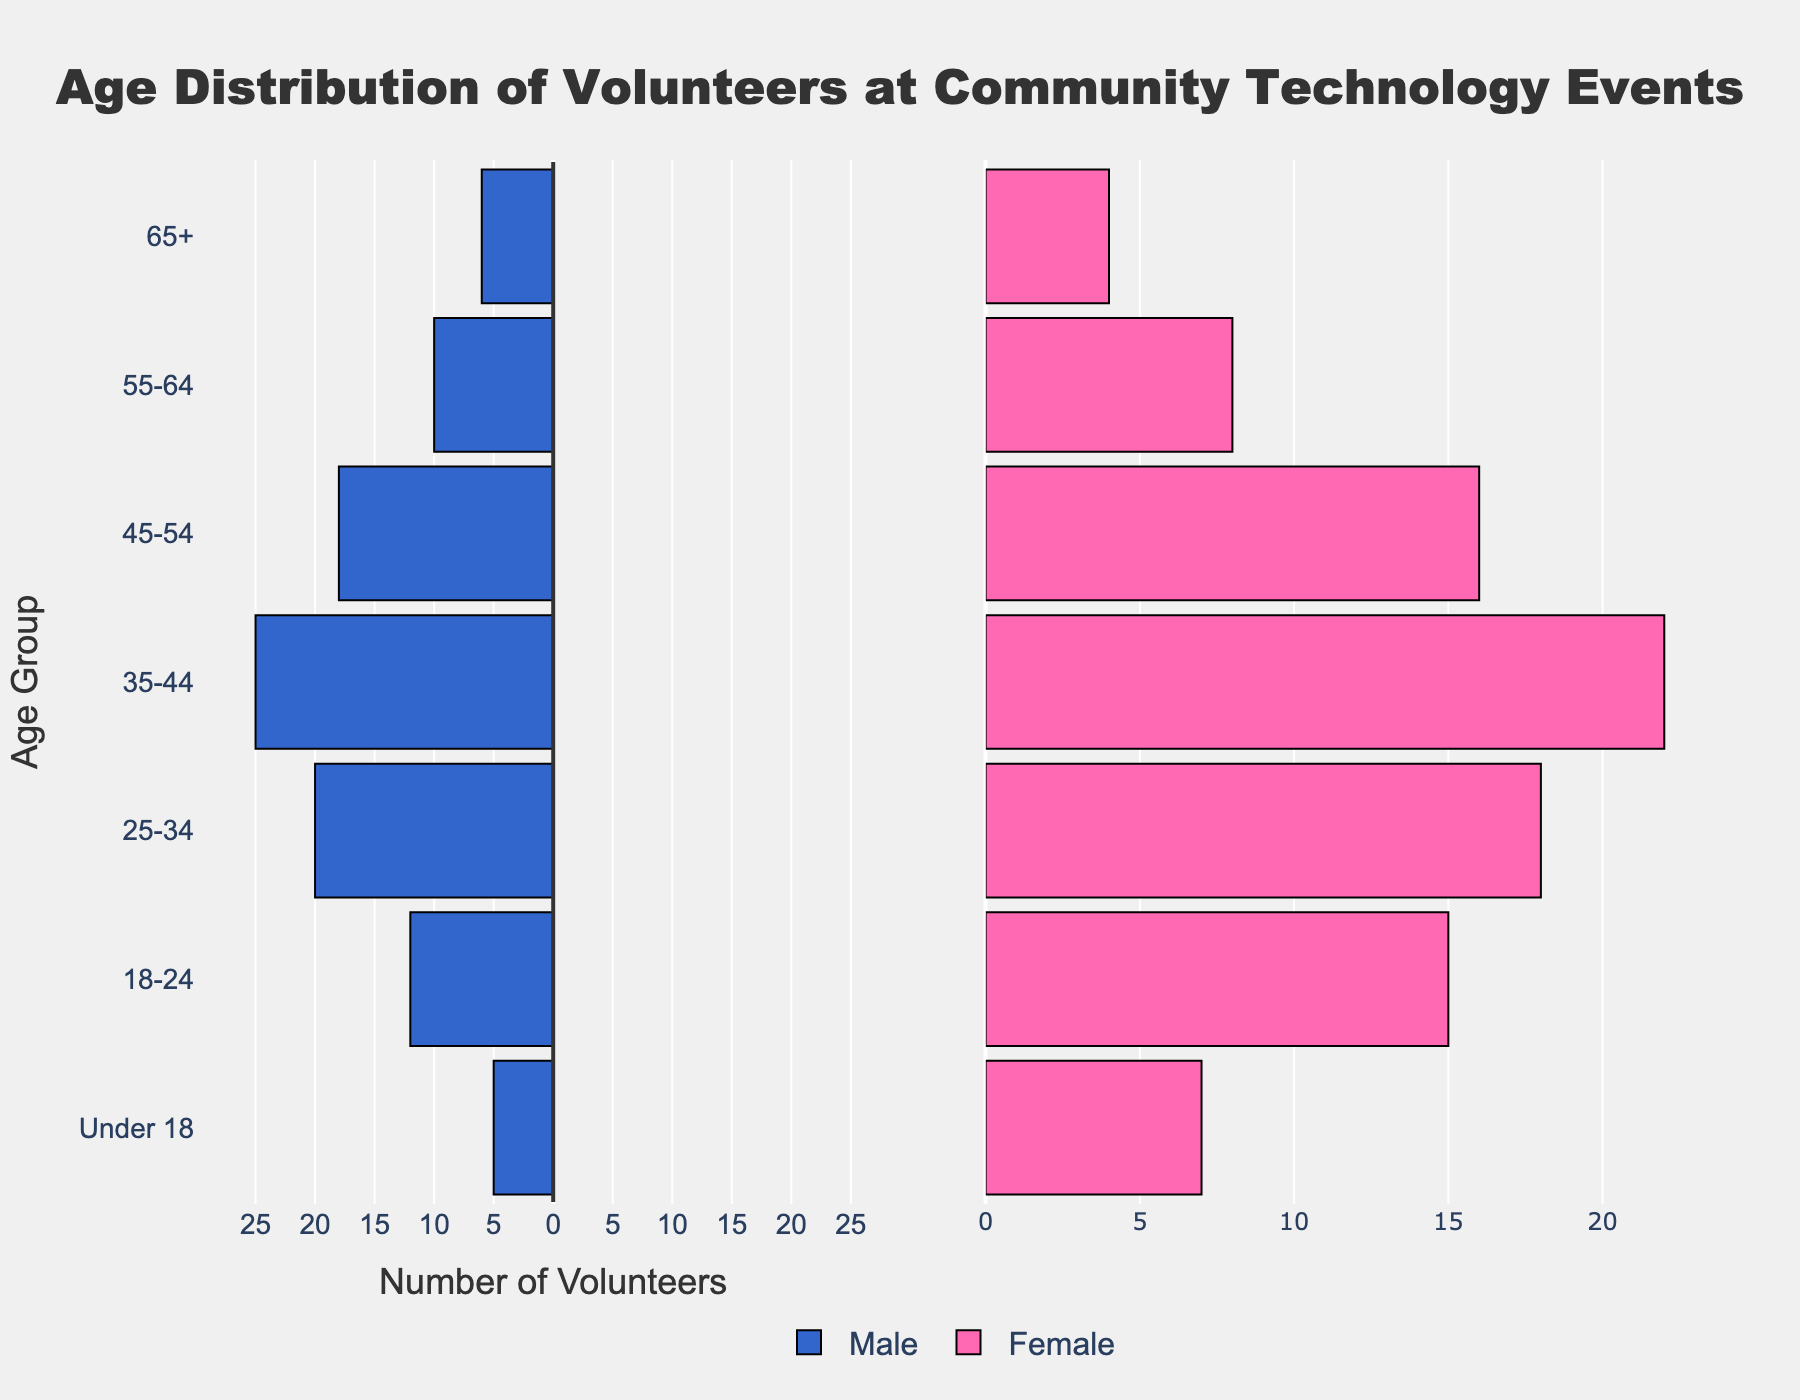What is the title of the figure? The title is usually displayed prominently at the top of the figure. In this case, the title text is 'Age Distribution of Volunteers at Community Technology Events'.
Answer: 'Age Distribution of Volunteers at Community Technology Events' What are the age groups available in the data? The age groups are listed on the y-axis of the figure. They are 'Under 18', '18-24', '25-34', '35-44', '45-54', '55-64', and '65+'.
Answer: 'Under 18', '18-24', '25-34', '35-44', '45-54', '55-64', '65+' What is the number of male volunteers in the age group 35-44? The figure displays male volunteer numbers in negative values on the left side. For the age group 35-44, the male bar extends to -25. This represents 25 male volunteers.
Answer: 25 Which gender has more volunteers in the age group 18-24? To determine this, compare the lengths of the bars for males and females in the age group 18-24. The female bar is slightly longer, indicating there are more female volunteers.
Answer: Female What is the total number of volunteers in the age group 45-54? Add the number of male and female volunteers for the age group 45-54. Males have 18, and females have 16, so the total is 18 + 16.
Answer: 34 Which age group has the highest number of total volunteers? Evaluate each age group by adding the male and female volunteers. The age group 35-44 has the highest numbers, with 25 males and 22 females, totaling 47.
Answer: 35-44 What is the difference between the number of female and male volunteers in age group 55-64? The number of male volunteers is 10, and the number of female volunteers is 8. The difference can be calculated as 10 - 8.
Answer: 2 Which age group has the smallest difference in volunteer numbers between genders? Calculate the absolute difference between male and female volunteers across all age groups and find the smallest difference. The age group 25-34 has a difference of 2 (20 males, 18 females).
Answer: 25-34 What is the combined number of male volunteers in the 'Under 18' and '65+' age groups? Add the male volunteers in the 'Under 18' (5) and '65+' (6) age groups. The total is 5 + 6.
Answer: 11 